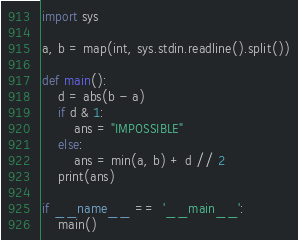<code> <loc_0><loc_0><loc_500><loc_500><_Python_>import sys

a, b = map(int, sys.stdin.readline().split())

def main():
    d = abs(b - a)
    if d & 1:
        ans = "IMPOSSIBLE"
    else:
        ans = min(a, b) + d // 2
    print(ans)

if __name__ ==  '__main__':
    main()</code> 